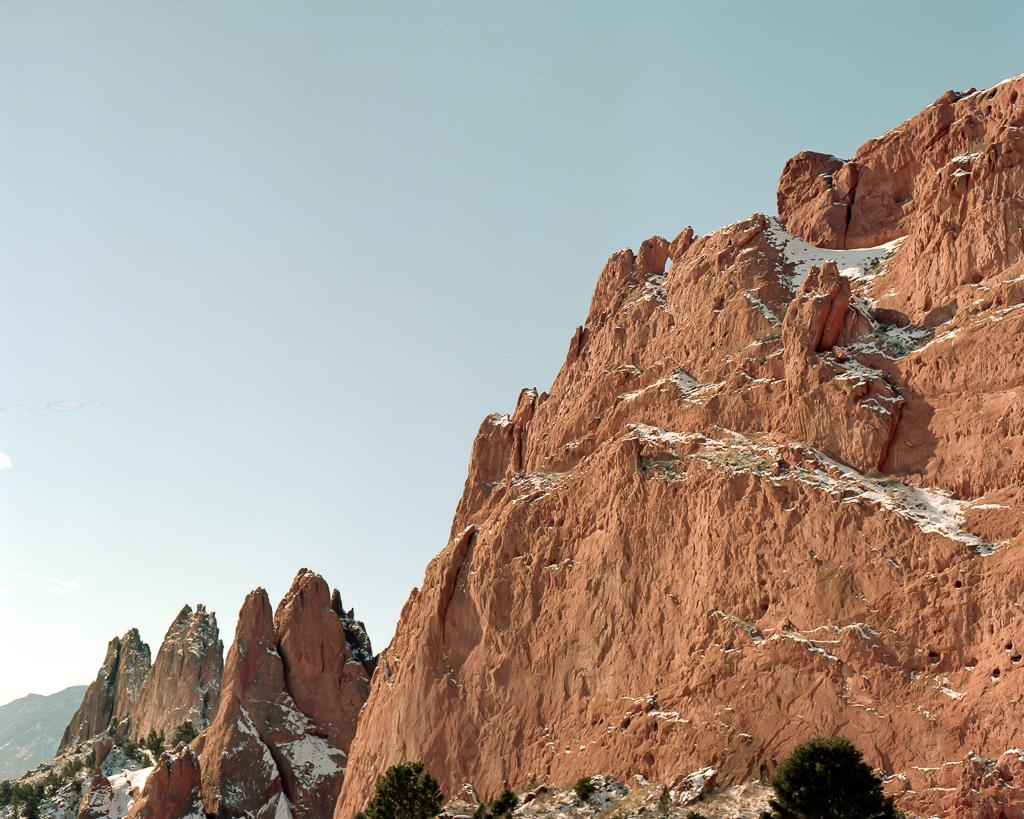What type of living organisms can be seen in the image? Plants can be seen in the image. What natural feature is covered in snow in the image? There is snow on the mountains in the image. What part of the natural environment is visible in the background of the image? The sky is visible in the background of the image. How many wings can be seen on the plants in the image? There are no wings visible on the plants in the image, as plants do not have wings. 